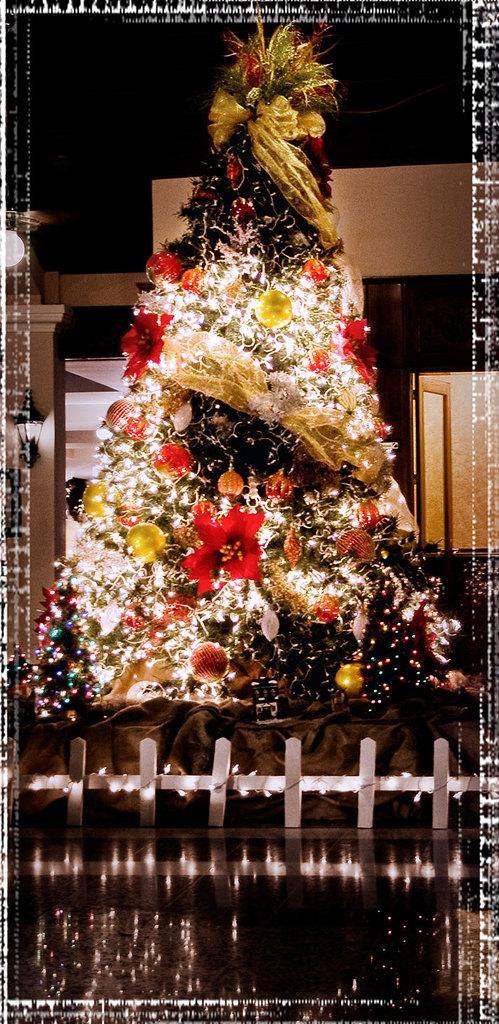In one or two sentences, can you explain what this image depicts? We can see Christmas tree with decorative items and lights. In the background we can see wall,light and window. 